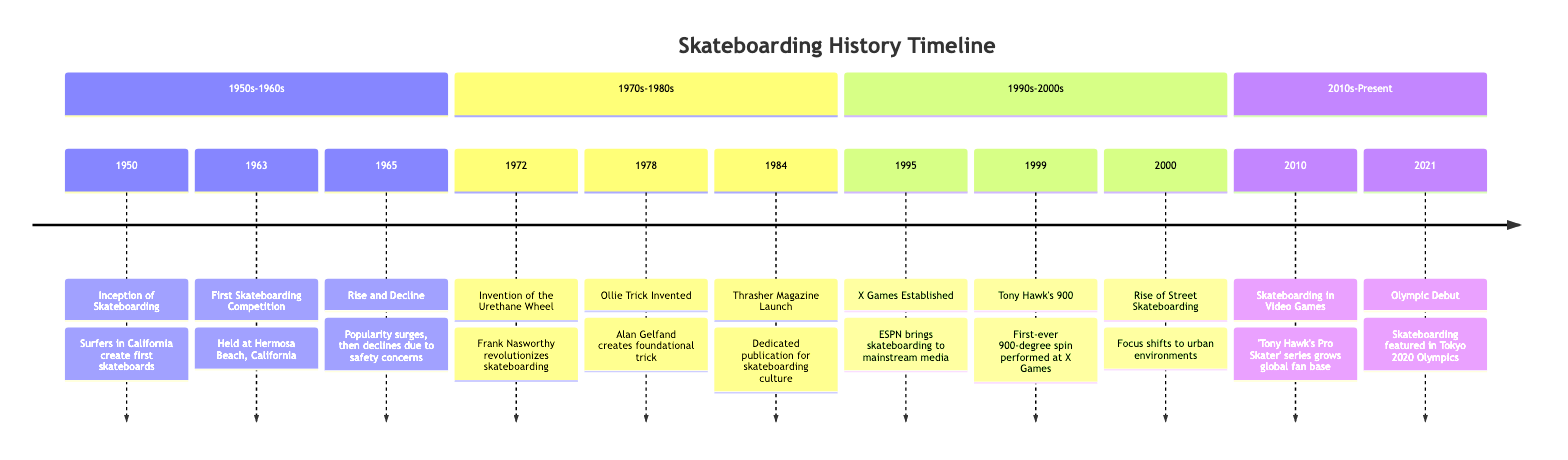What year did skateboarding begin? The diagram shows the inception of skateboarding in 1950 at the beginning of the timeline. Thus, the answer can be directly taken from the first event listed.
Answer: 1950 What event marked the rise of street skateboarding? Looking at the timeline, the event that signifies the rise of street skateboarding is stated for the year 2000. This event is mentioned specifically, making it clear.
Answer: Rise of Street Skateboarding How long after the first skateboarding competition did the invention of the urethane wheel occur? The first skateboarding competition was in 1963 and the invention of the urethane wheel occurred in 1972. To find the time difference, you subtract 1963 from 1972, which gives 9 years.
Answer: 9 years What publication launched in 1984 contributed to skateboarding culture? The timeline specifically mentions the launch of Thrasher Magazine in 1984, which was a dedicated publication for skateboarding culture. Therefore, the answer is based on the direct reference in the timeline.
Answer: Thrasher Magazine What notable trick was invented in 1978? The timeline indicates that the 'ollie' trick was invented in 1978 by Alan Gelfand. This is a specific fact highlighted in the event description of that year.
Answer: Ollie Which event in 1999 was a significant milestone for Tony Hawk? The event listed for 1999 is Tony Hawk's performance of the first-ever 900-degree spin at the X Games, which is clearly defined in the timeline. Thus, this event serves as the answer.
Answer: Tony Hawk's 900 In which decade did skateboarding make its Olympic debut? The timeline shows that the Olympic debut of skateboarding occurred in 2021, and this event is categorized under the 2010s-Present section. Identifying the decade relates it to its position within the timeline.
Answer: 2020s What was the first skateboarding competition location? According to the timeline, the first skateboarding competition was held at Hermosa Beach, California. This information is provided directly within the event description for 1963.
Answer: Hermosa Beach What year saw the beginning of skateboarding's decline? The timeline states that skateboarding began to decline in popularity around 1965, due to various concerns, making it a clear point in the historical timeline.
Answer: 1965 